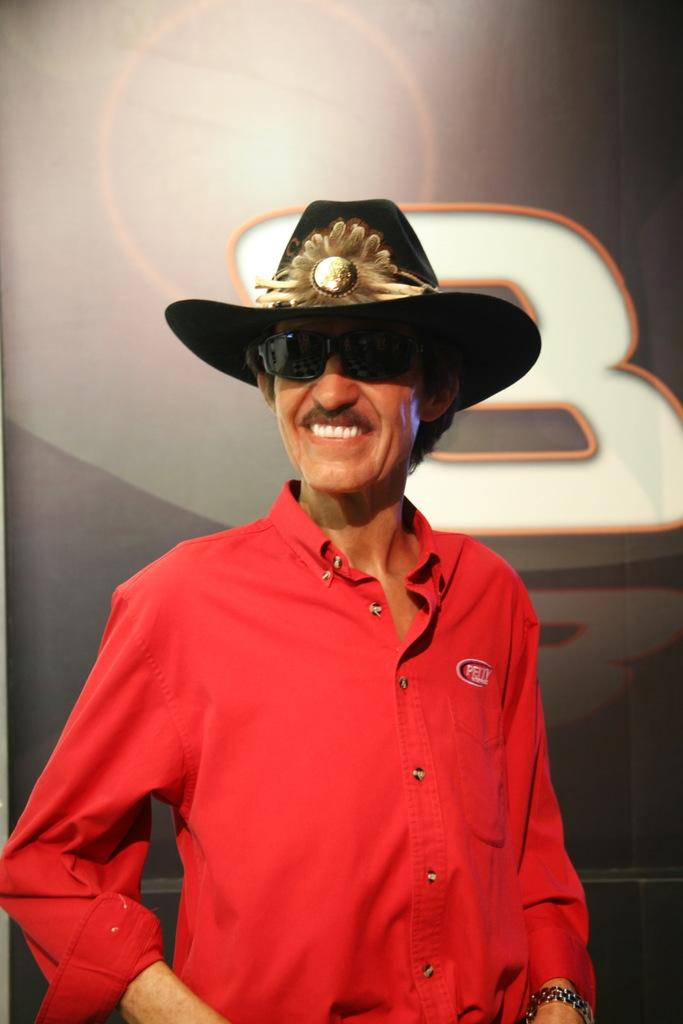What is the main subject of the image? The main subject of the image is a man standing in the middle. What is the man wearing on his upper body? The man is wearing a red color shirt. What headgear is the man wearing? The man is wearing a hat. What type of eyewear is the man wearing? The man is wearing black color specs. What can be seen in the background of the image? There is a poster in the background of the image. What type of bit is the man using to control the train in the image? There is no train or bit present in the image; it features a man standing in the middle with a hat and black specs. 